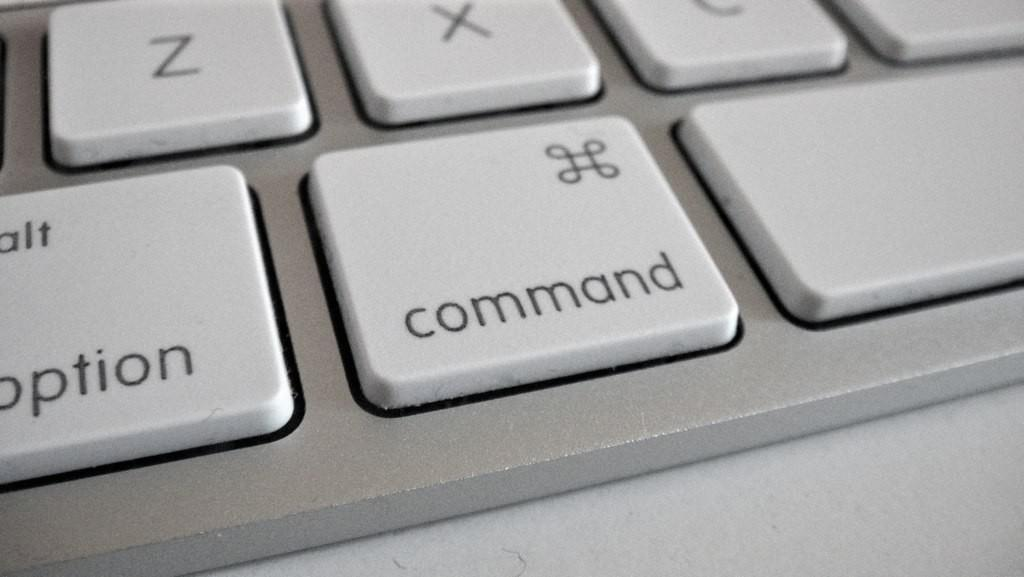<image>
Create a compact narrative representing the image presented. The command key on a keyboard is right next to the option key. 